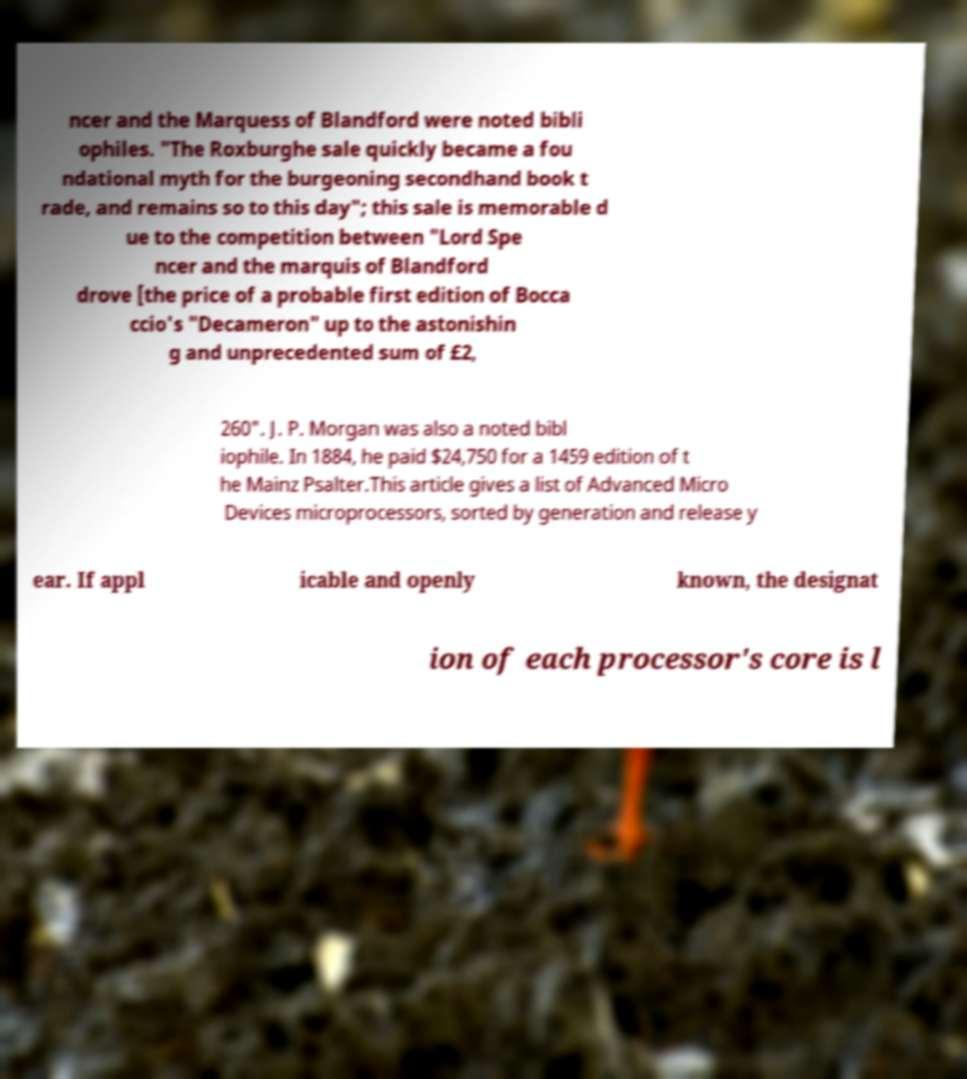Could you assist in decoding the text presented in this image and type it out clearly? ncer and the Marquess of Blandford were noted bibli ophiles. "The Roxburghe sale quickly became a fou ndational myth for the burgeoning secondhand book t rade, and remains so to this day"; this sale is memorable d ue to the competition between "Lord Spe ncer and the marquis of Blandford drove [the price of a probable first edition of Bocca ccio's "Decameron" up to the astonishin g and unprecedented sum of £2, 260". J. P. Morgan was also a noted bibl iophile. In 1884, he paid $24,750 for a 1459 edition of t he Mainz Psalter.This article gives a list of Advanced Micro Devices microprocessors, sorted by generation and release y ear. If appl icable and openly known, the designat ion of each processor's core is l 